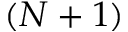<formula> <loc_0><loc_0><loc_500><loc_500>( N + 1 )</formula> 